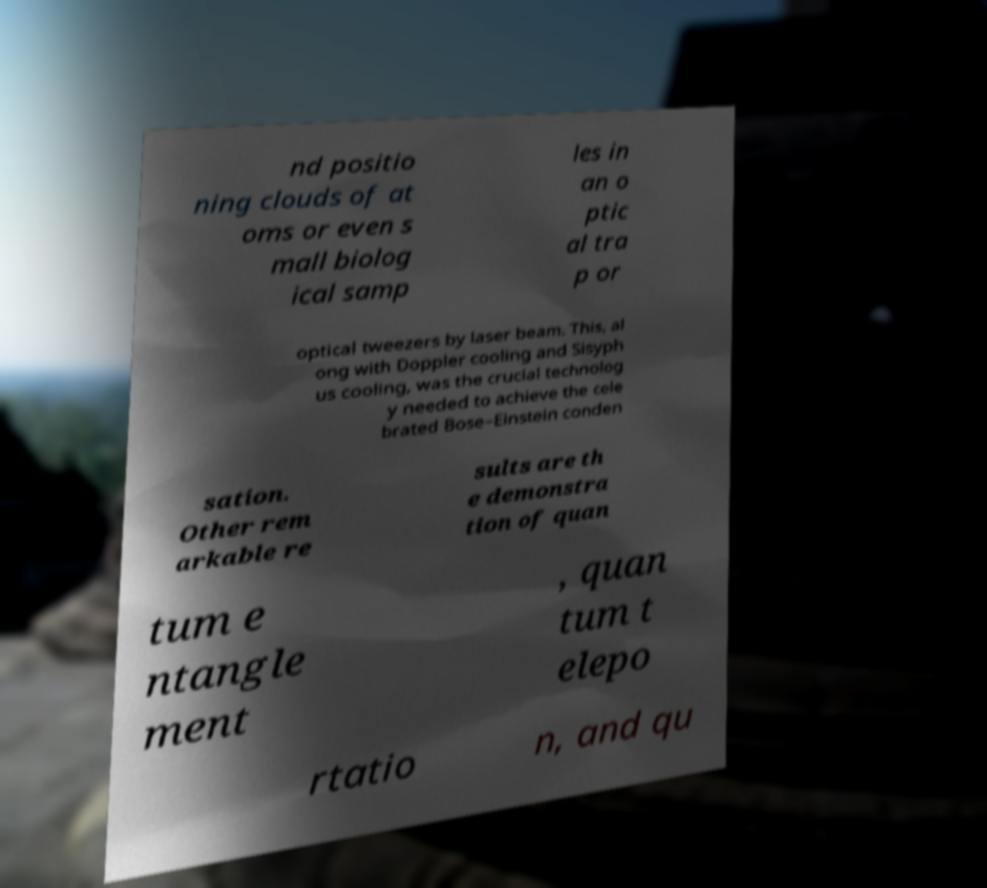Could you extract and type out the text from this image? nd positio ning clouds of at oms or even s mall biolog ical samp les in an o ptic al tra p or optical tweezers by laser beam. This, al ong with Doppler cooling and Sisyph us cooling, was the crucial technolog y needed to achieve the cele brated Bose–Einstein conden sation. Other rem arkable re sults are th e demonstra tion of quan tum e ntangle ment , quan tum t elepo rtatio n, and qu 